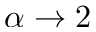Convert formula to latex. <formula><loc_0><loc_0><loc_500><loc_500>\alpha \rightarrow 2</formula> 